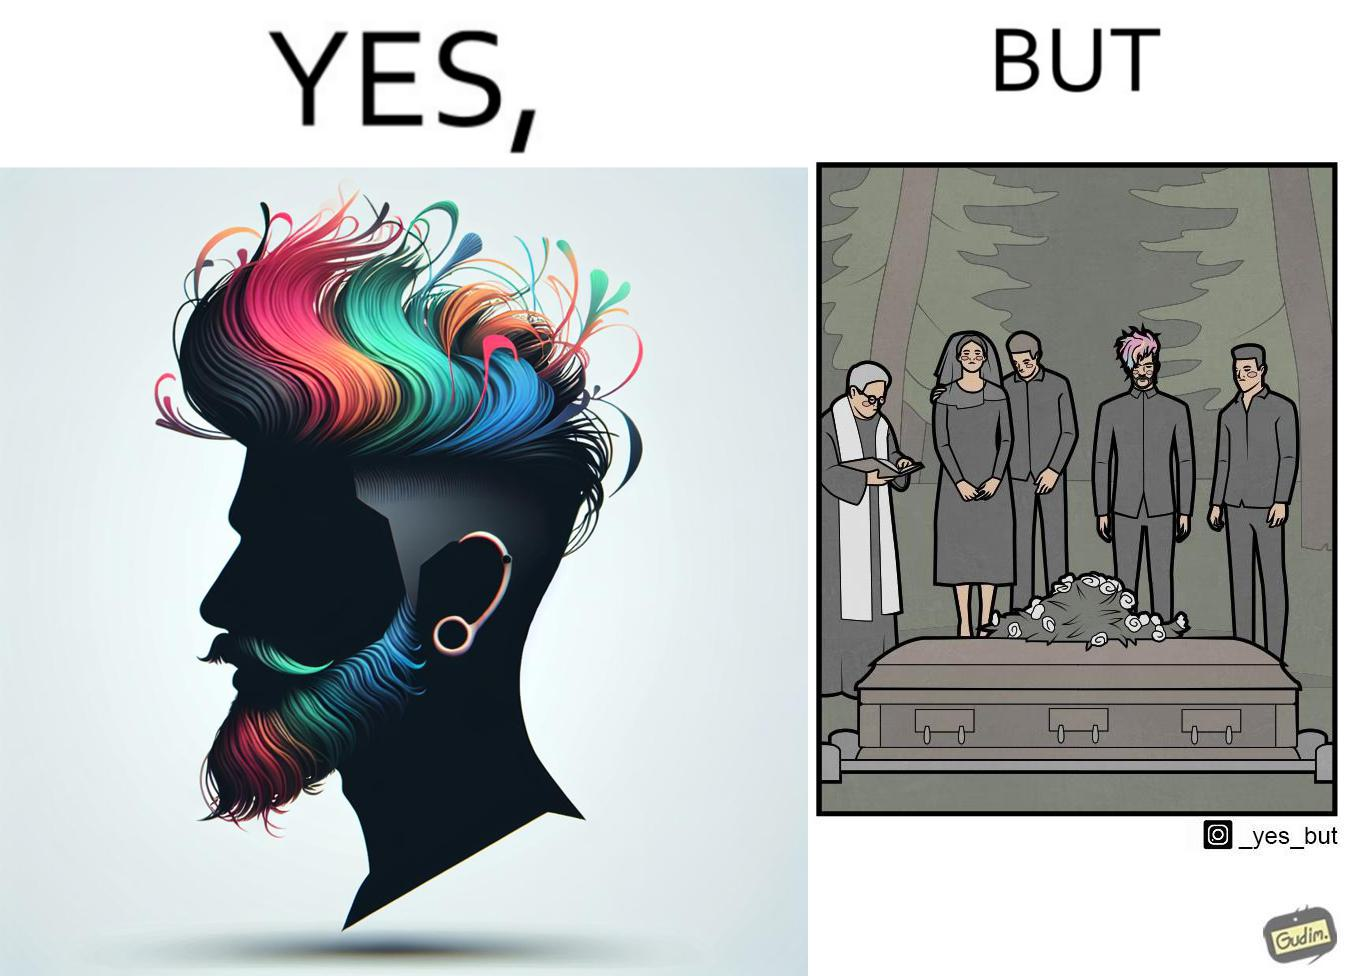What is shown in the left half versus the right half of this image? In the left part of the image: a person with colorful hairstyle, stylish beard at ear piercings In the right part of the image: a group of persons at the death ceremony of some person performing the last rituals 